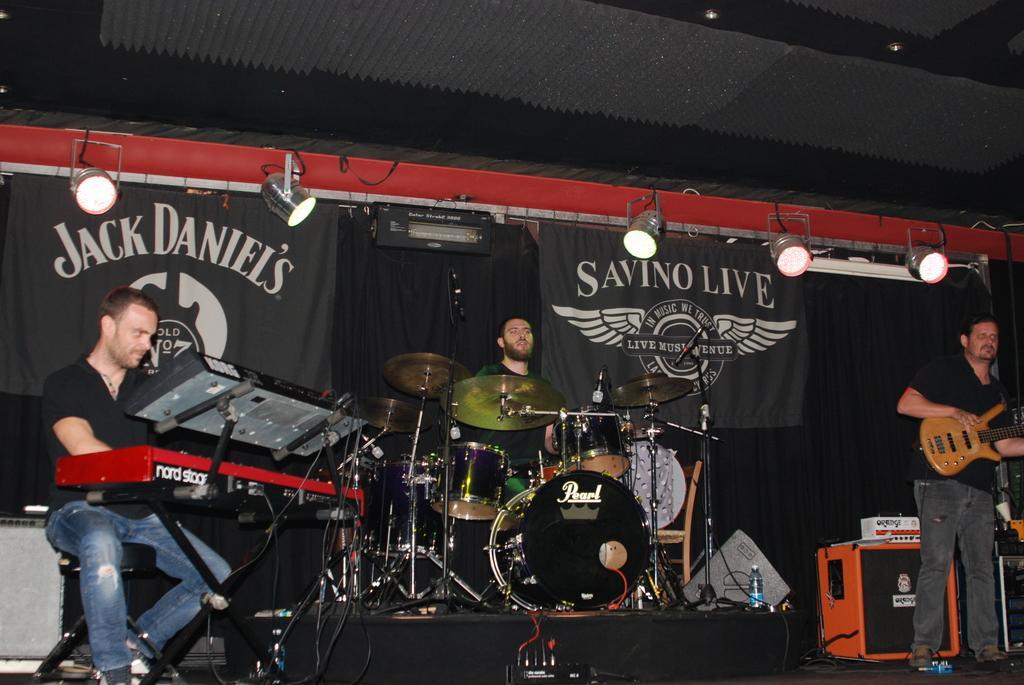Could you give a brief overview of what you see in this image? In this image I see 3 men and all of them are playing an musical instrument. In the background I can see the curtains and few lights. 